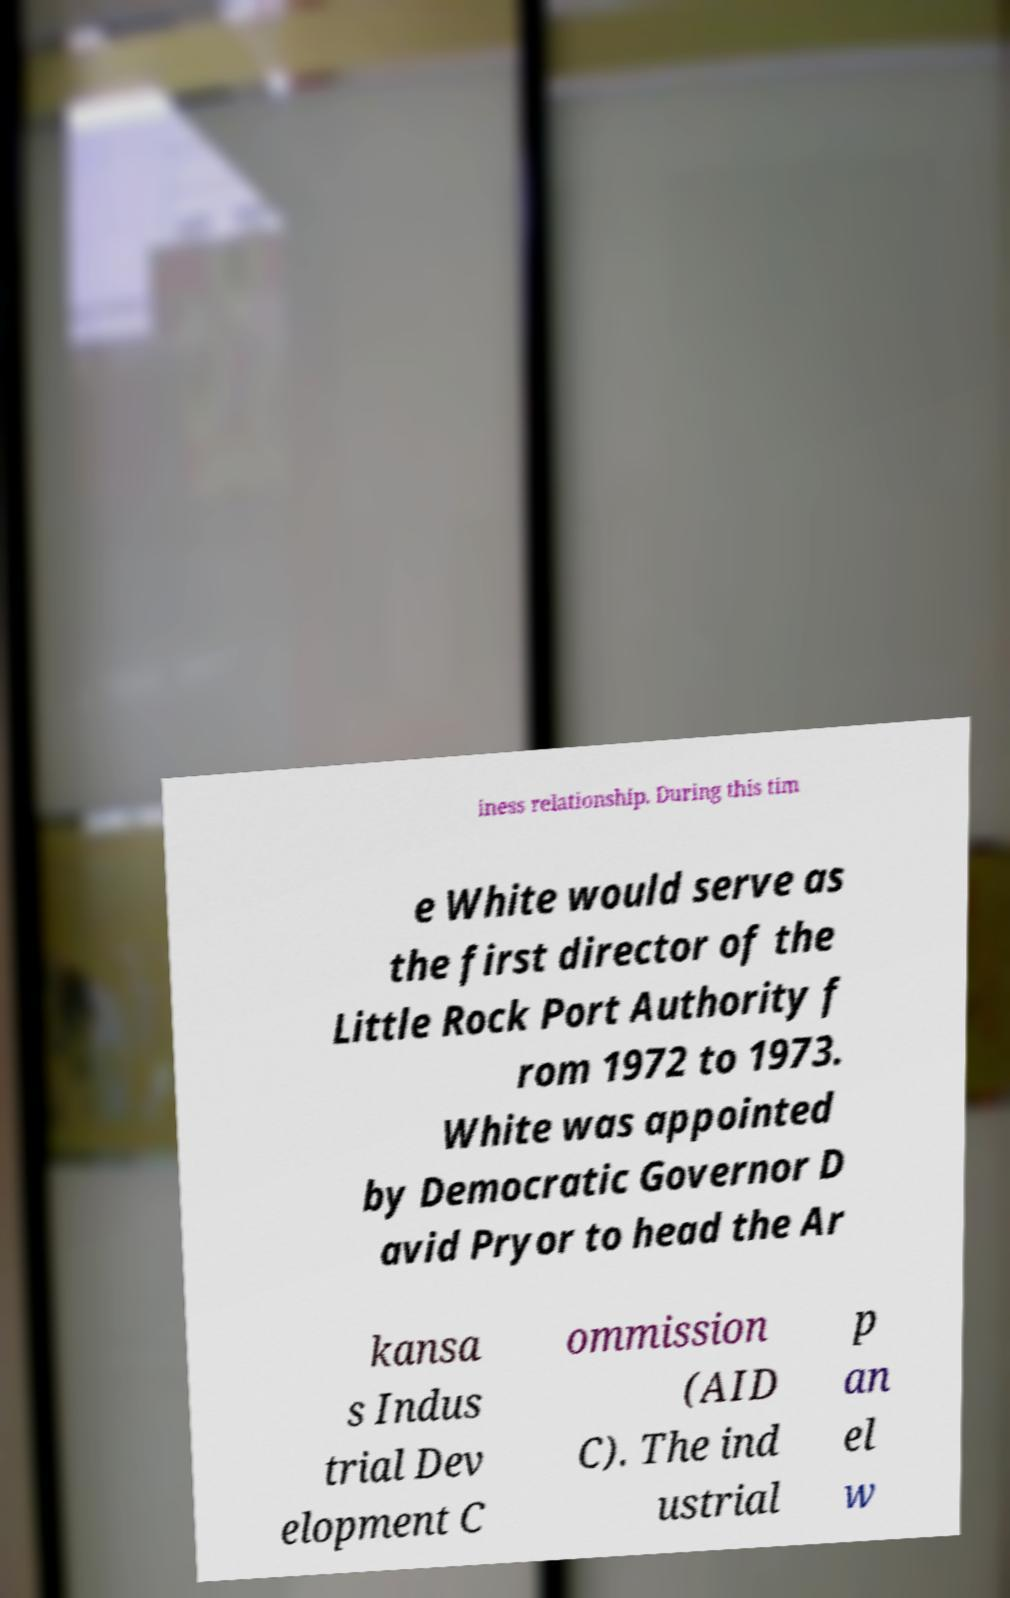Can you read and provide the text displayed in the image?This photo seems to have some interesting text. Can you extract and type it out for me? iness relationship. During this tim e White would serve as the first director of the Little Rock Port Authority f rom 1972 to 1973. White was appointed by Democratic Governor D avid Pryor to head the Ar kansa s Indus trial Dev elopment C ommission (AID C). The ind ustrial p an el w 